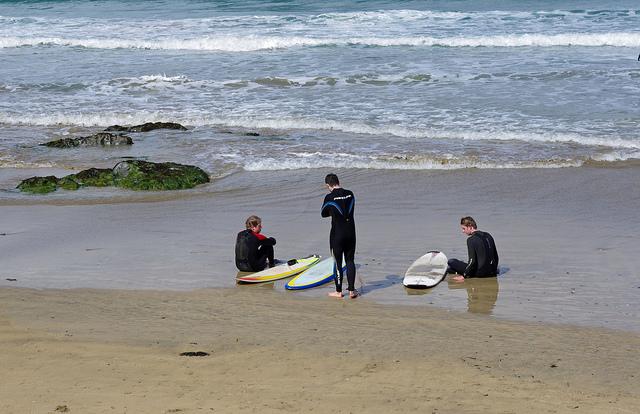How can you tell the water isn't very warm?
Give a very brief answer. Wearing wetsuits. Where was the picture taken?
Quick response, please. Beach. Are they there to build sand castles?
Short answer required. No. Is the man going to surf?
Be succinct. Yes. How many people are in  the photo?
Short answer required. 3. How many people are sitting on surfboards?
Quick response, please. 0. Why are they standing around?
Concise answer only. Waiting for wave. What are they sitting on?
Answer briefly. Sand. 